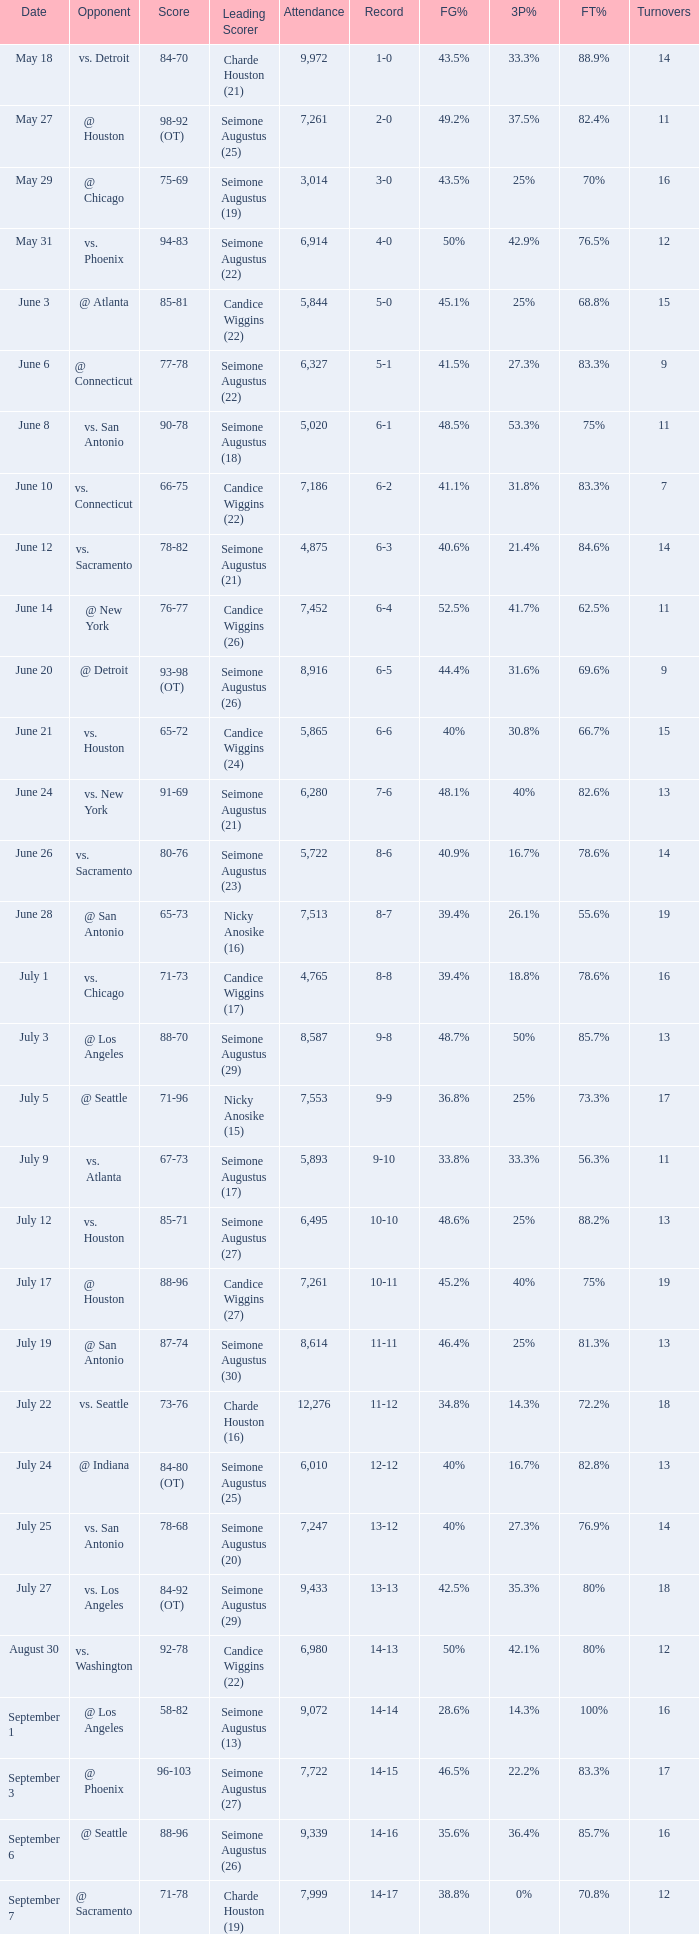Which Attendance has a Date of september 7? 7999.0. 